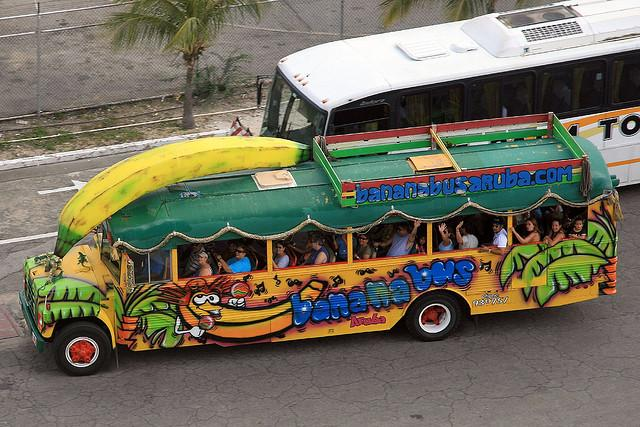Which one of these is a sister island to this location? Please explain your reasoning. bonaire. The markings on the side of the vehicle indicate that it is the aruba banana bus. jamaica, barbados, and cuba are not sister islands to aruba. 